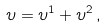<formula> <loc_0><loc_0><loc_500><loc_500>\upsilon = \upsilon ^ { 1 } + \upsilon ^ { 2 } \, ,</formula> 